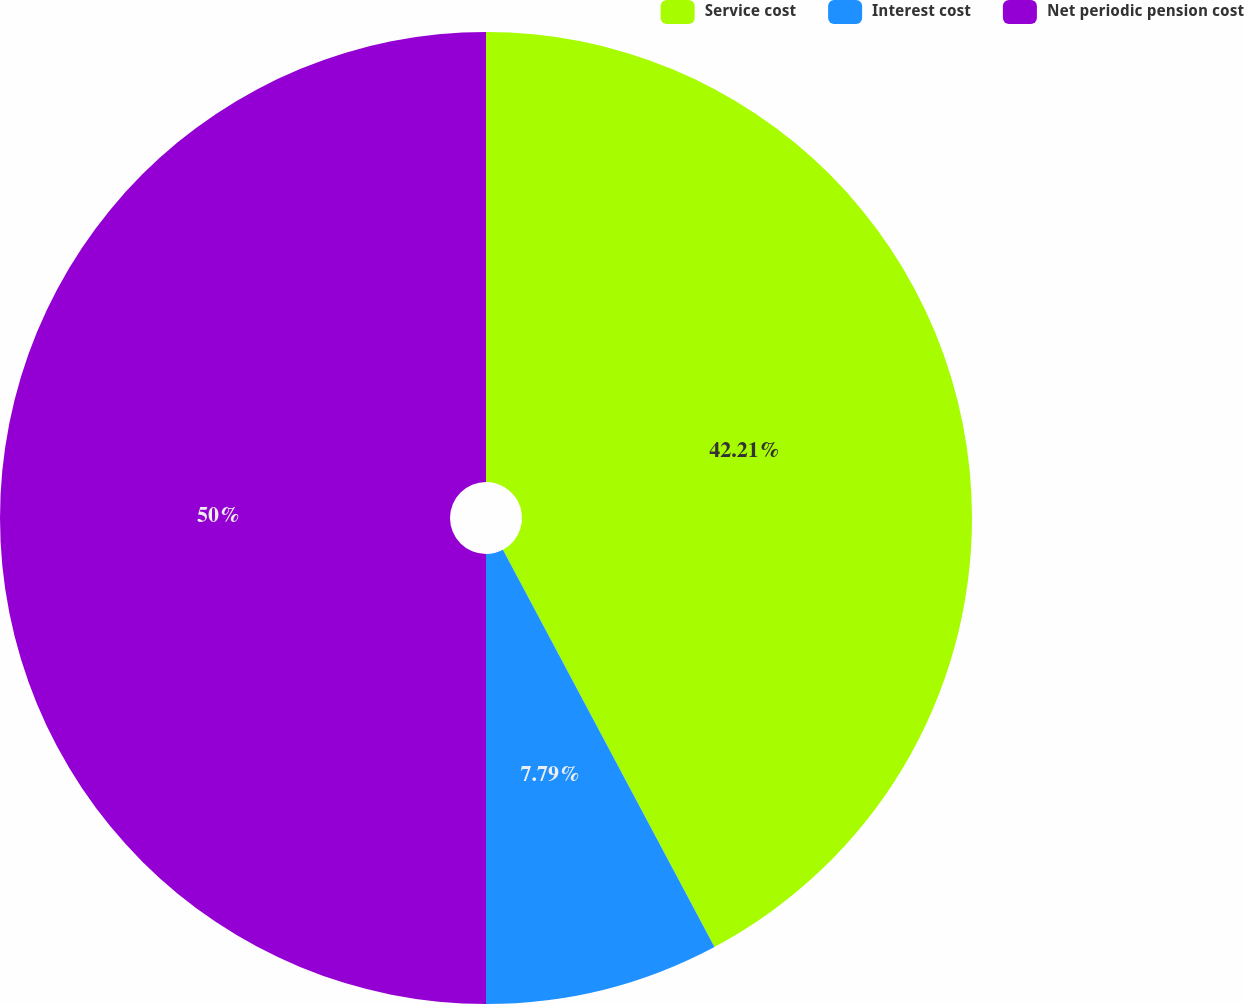Convert chart. <chart><loc_0><loc_0><loc_500><loc_500><pie_chart><fcel>Service cost<fcel>Interest cost<fcel>Net periodic pension cost<nl><fcel>42.21%<fcel>7.79%<fcel>50.0%<nl></chart> 